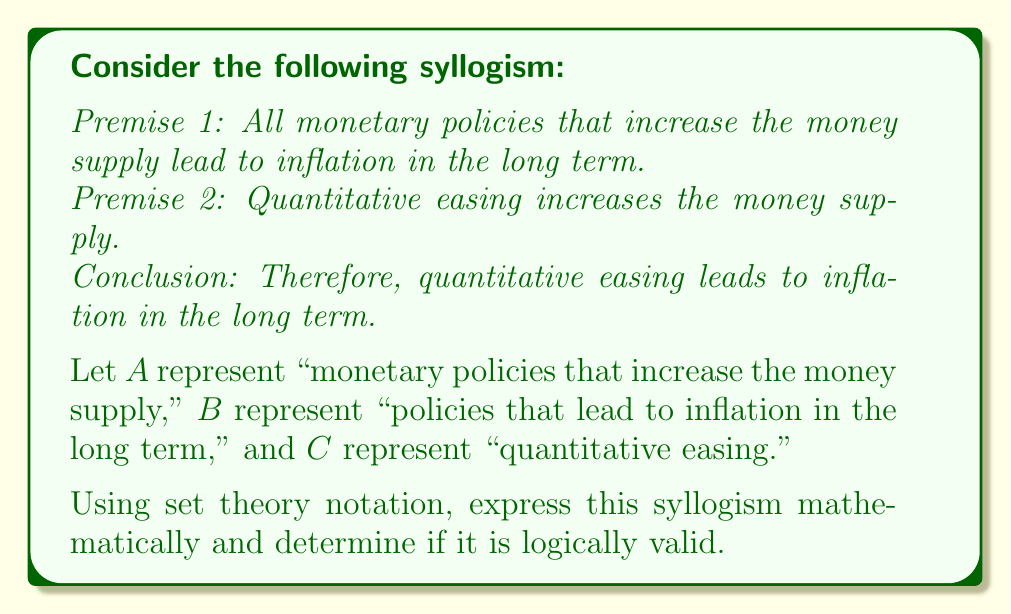Can you solve this math problem? To analyze this syllogism using mathematical logic, we'll express each premise and the conclusion using set theory notation:

Premise 1: $A \subseteq B$
This means that all elements in set $A$ are also in set $B$.

Premise 2: $C \subseteq A$
This means that all elements in set $C$ are also in set $A$.

Conclusion: $C \subseteq B$
This is the claim we need to prove or disprove.

To determine if the syllogism is logically valid, we need to see if the conclusion necessarily follows from the premises. We can use the property of transitivity in set theory:

If $X \subseteq Y$ and $Y \subseteq Z$, then $X \subseteq Z$

In our case:
$C \subseteq A$ (Premise 2)
$A \subseteq B$ (Premise 1)

Therefore, by transitivity:
$C \subseteq B$

This matches our conclusion, which means the syllogism is logically valid.

We can also visualize this using a Venn diagram:

[asy]
unitsize(1cm);

draw(circle((0,0),2));
draw(circle((1,0),2));
draw(circle((0.5,0),1));

label("A", (-1,0));
label("B", (2,0));
label("C", (0.5,0));
[/asy]

In this diagram, we can see that set $C$ is entirely contained within set $A$, which is in turn entirely contained within set $B$. This visual representation confirms the logical validity of the syllogism.
Answer: The syllogism is logically valid. Using set theory notation:

Given: $A \subseteq B$ and $C \subseteq A$
Conclusion: $C \subseteq B$ (valid by transitivity of set inclusion) 